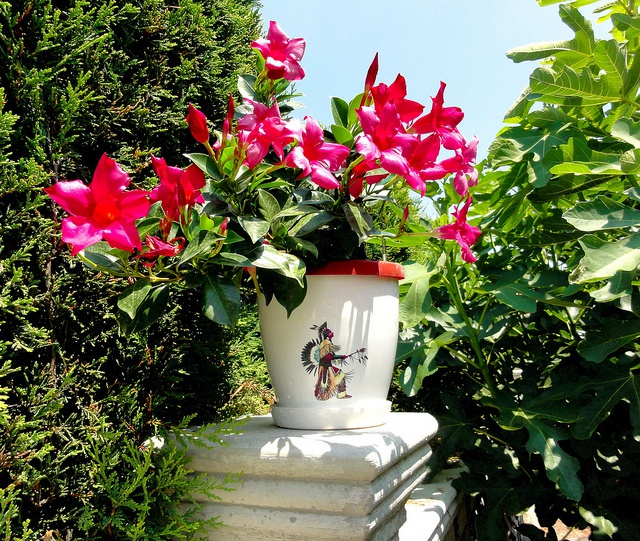Describe the objects in this image and their specific colors. I can see potted plant in darkgreen, black, white, and brown tones and vase in darkgreen, ivory, darkgray, tan, and black tones in this image. 